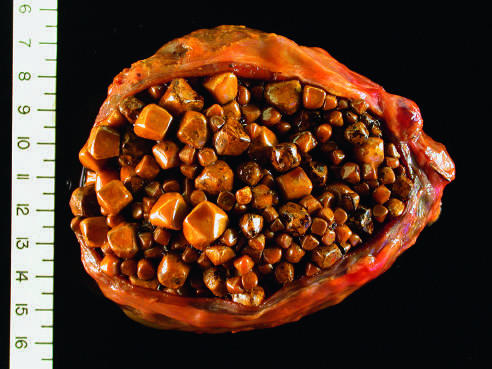s the wall of the gallbladder thickened and fibrotic due to chronic cholecystitis?
Answer the question using a single word or phrase. Yes 